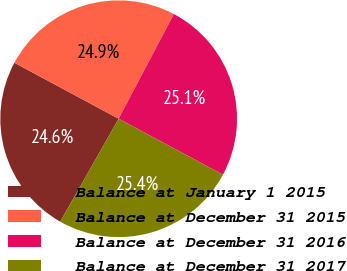Convert chart to OTSL. <chart><loc_0><loc_0><loc_500><loc_500><pie_chart><fcel>Balance at January 1 2015<fcel>Balance at December 31 2015<fcel>Balance at December 31 2016<fcel>Balance at December 31 2017<nl><fcel>24.63%<fcel>24.88%<fcel>25.12%<fcel>25.37%<nl></chart> 